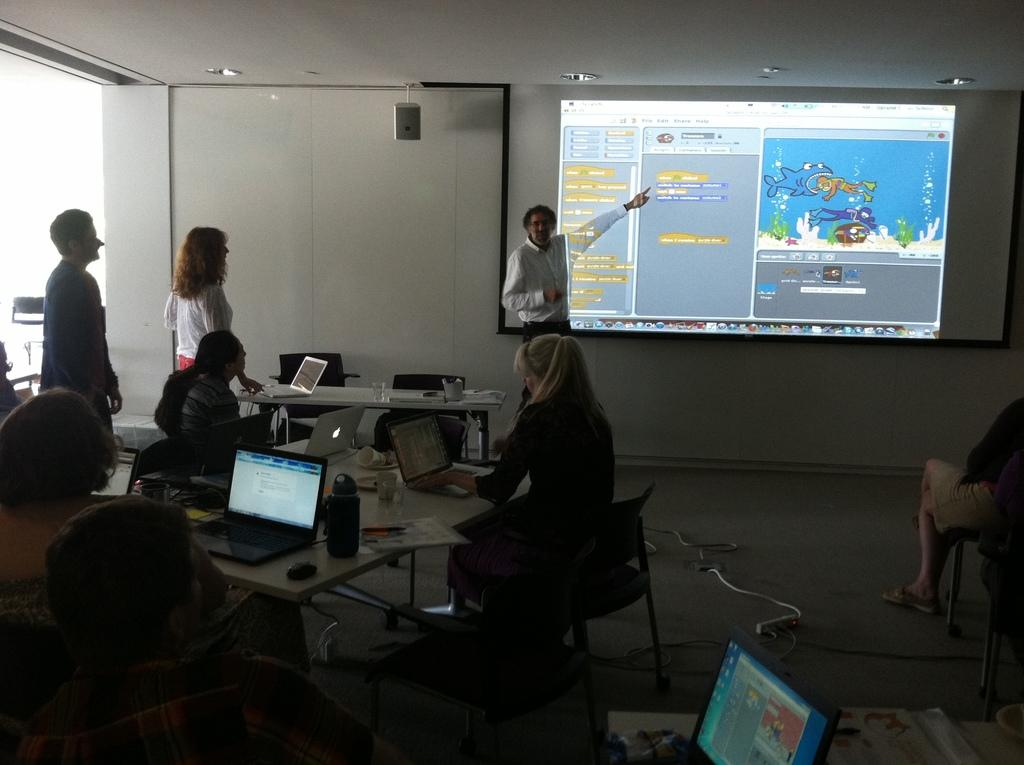How many people are in the image? There is a group of people in the image. What is the man in the image doing? The man is presenting in the image. What is behind the man in the image? The man is standing in front of a screen. How many cats are sitting on the man's shoulders in the image? There are no cats present in the image; the man is standing in front of a screen while presenting to a group of people. 